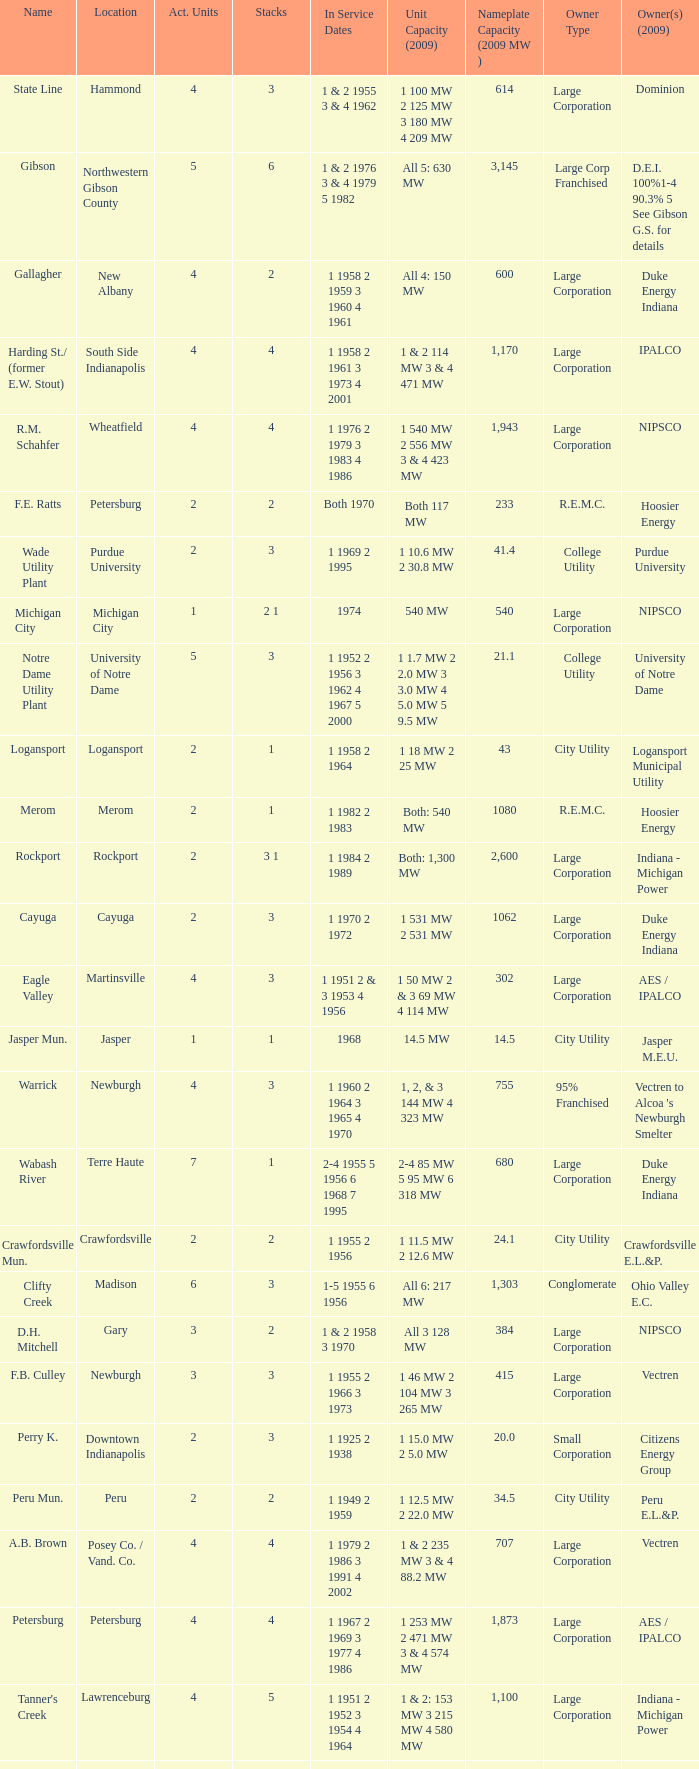Name the owners 2009 for south side indianapolis IPALCO. 